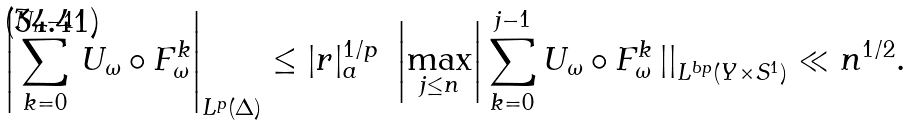<formula> <loc_0><loc_0><loc_500><loc_500>\left | \sum _ { k = 0 } ^ { N _ { n } - 1 } U _ { \omega } \circ F _ { \omega } ^ { k } \right | _ { L ^ { p } ( \Delta ) } \leq | r | _ { a } ^ { 1 / p } \ \left | \max _ { j \leq n } \right | \sum _ { k = 0 } ^ { j - 1 } U _ { \omega } \circ F _ { \omega } ^ { k } \left | \right | _ { L ^ { b p } ( Y \times S ^ { 1 } ) } \ll n ^ { 1 / 2 } .</formula> 